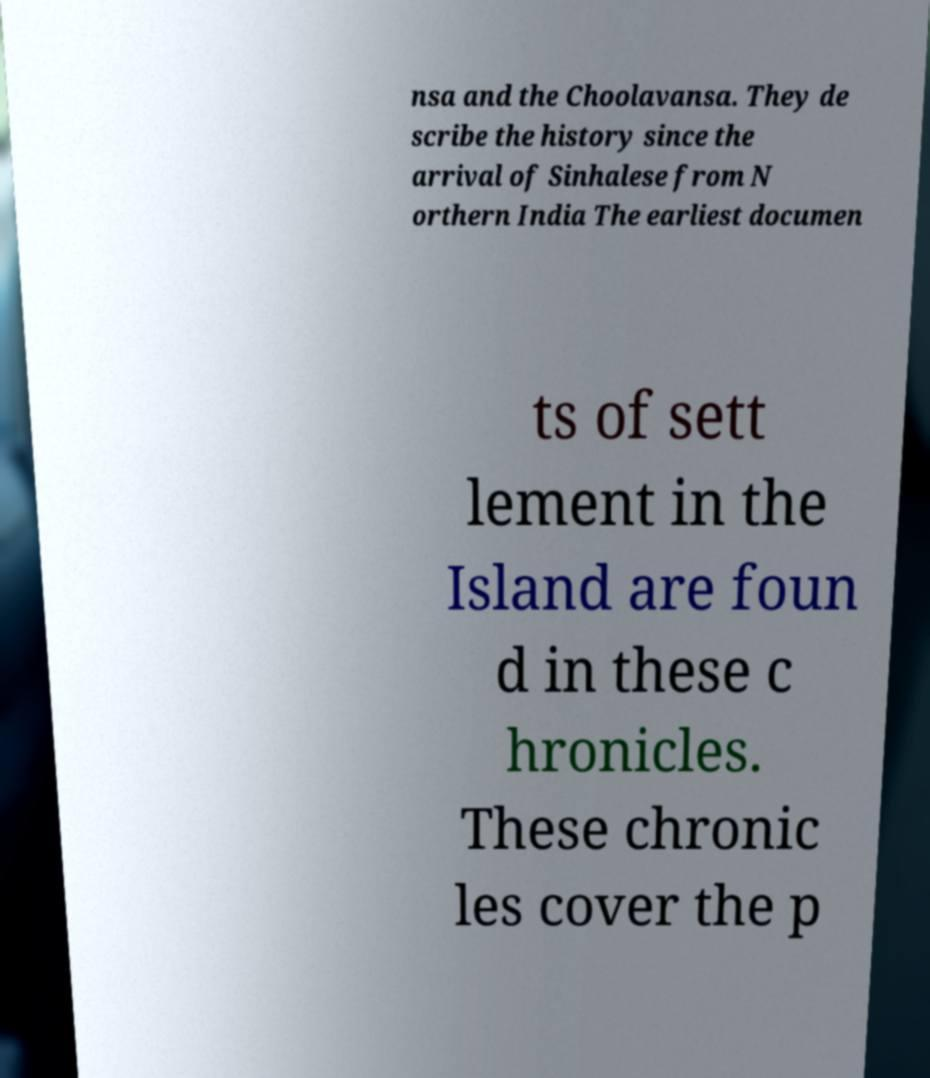For documentation purposes, I need the text within this image transcribed. Could you provide that? nsa and the Choolavansa. They de scribe the history since the arrival of Sinhalese from N orthern India The earliest documen ts of sett lement in the Island are foun d in these c hronicles. These chronic les cover the p 